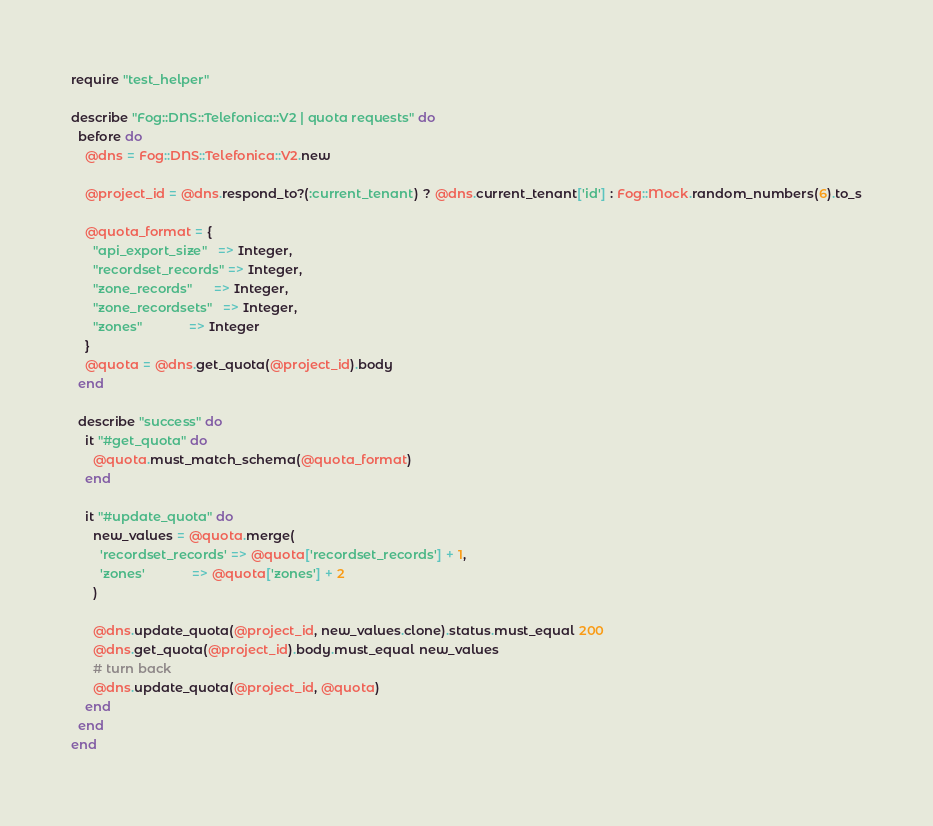Convert code to text. <code><loc_0><loc_0><loc_500><loc_500><_Ruby_>require "test_helper"

describe "Fog::DNS::Telefonica::V2 | quota requests" do
  before do
    @dns = Fog::DNS::Telefonica::V2.new

    @project_id = @dns.respond_to?(:current_tenant) ? @dns.current_tenant['id'] : Fog::Mock.random_numbers(6).to_s

    @quota_format = {
      "api_export_size"   => Integer,
      "recordset_records" => Integer,
      "zone_records"      => Integer,
      "zone_recordsets"   => Integer,
      "zones"             => Integer
    }
    @quota = @dns.get_quota(@project_id).body
  end

  describe "success" do
    it "#get_quota" do
      @quota.must_match_schema(@quota_format)
    end

    it "#update_quota" do
      new_values = @quota.merge(
        'recordset_records' => @quota['recordset_records'] + 1,
        'zones'             => @quota['zones'] + 2
      )

      @dns.update_quota(@project_id, new_values.clone).status.must_equal 200
      @dns.get_quota(@project_id).body.must_equal new_values
      # turn back
      @dns.update_quota(@project_id, @quota)
    end
  end
end
</code> 